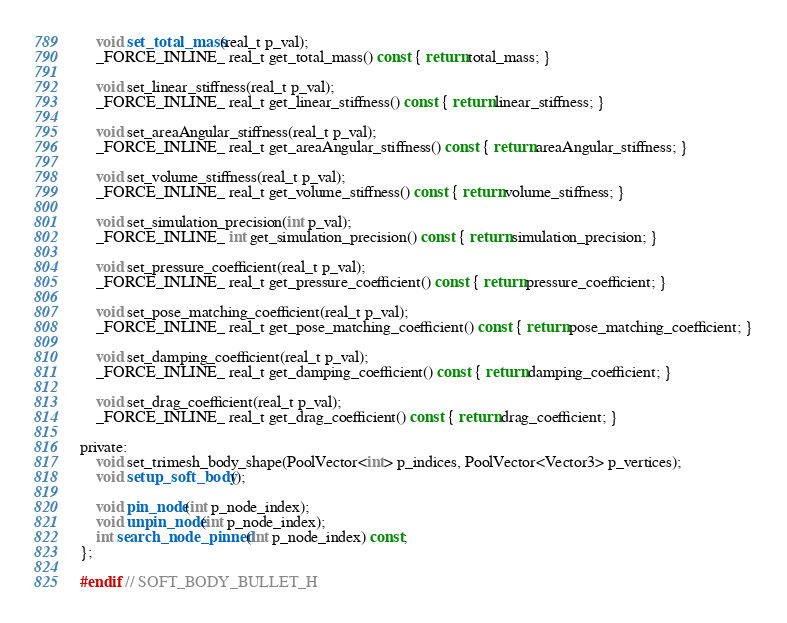Convert code to text. <code><loc_0><loc_0><loc_500><loc_500><_C_>	void set_total_mass(real_t p_val);
	_FORCE_INLINE_ real_t get_total_mass() const { return total_mass; }

	void set_linear_stiffness(real_t p_val);
	_FORCE_INLINE_ real_t get_linear_stiffness() const { return linear_stiffness; }

	void set_areaAngular_stiffness(real_t p_val);
	_FORCE_INLINE_ real_t get_areaAngular_stiffness() const { return areaAngular_stiffness; }

	void set_volume_stiffness(real_t p_val);
	_FORCE_INLINE_ real_t get_volume_stiffness() const { return volume_stiffness; }

	void set_simulation_precision(int p_val);
	_FORCE_INLINE_ int get_simulation_precision() const { return simulation_precision; }

	void set_pressure_coefficient(real_t p_val);
	_FORCE_INLINE_ real_t get_pressure_coefficient() const { return pressure_coefficient; }

	void set_pose_matching_coefficient(real_t p_val);
	_FORCE_INLINE_ real_t get_pose_matching_coefficient() const { return pose_matching_coefficient; }

	void set_damping_coefficient(real_t p_val);
	_FORCE_INLINE_ real_t get_damping_coefficient() const { return damping_coefficient; }

	void set_drag_coefficient(real_t p_val);
	_FORCE_INLINE_ real_t get_drag_coefficient() const { return drag_coefficient; }

private:
	void set_trimesh_body_shape(PoolVector<int> p_indices, PoolVector<Vector3> p_vertices);
	void setup_soft_body();

	void pin_node(int p_node_index);
	void unpin_node(int p_node_index);
	int search_node_pinned(int p_node_index) const;
};

#endif // SOFT_BODY_BULLET_H
</code> 